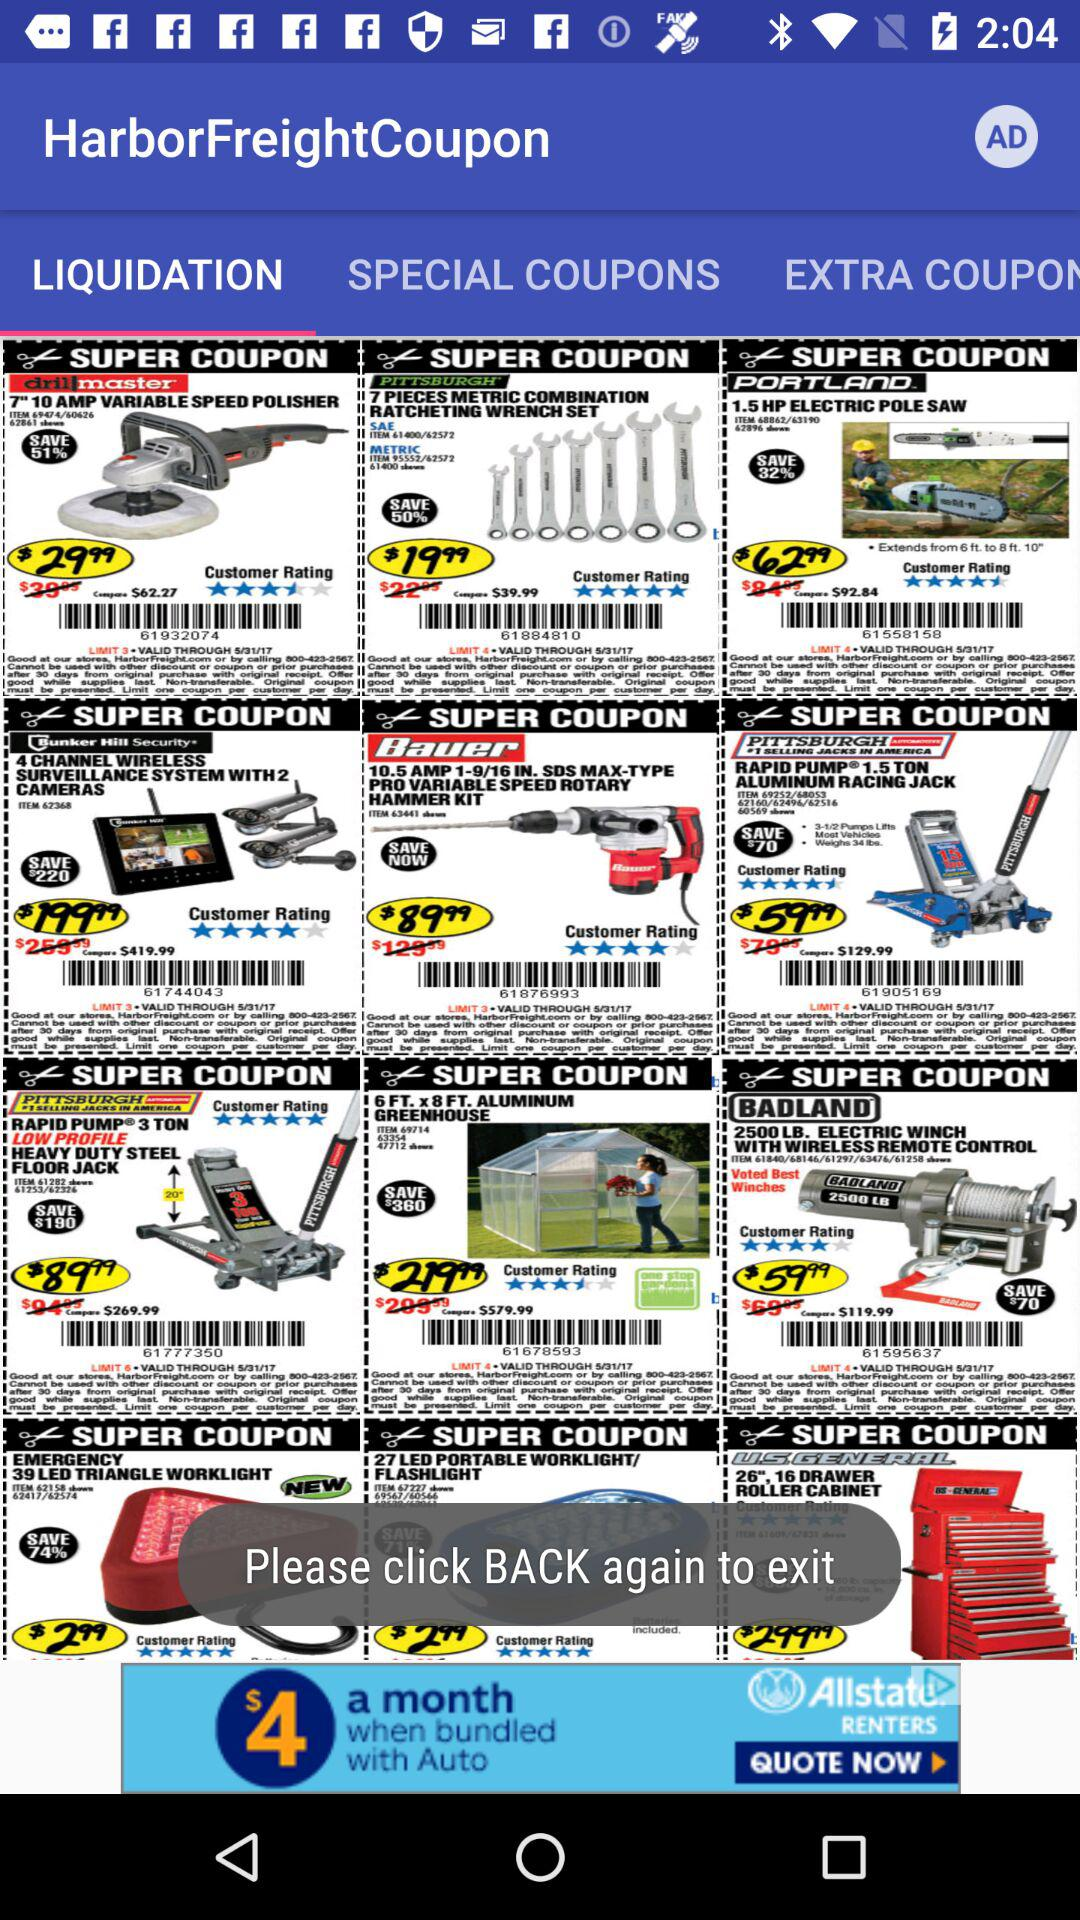Which tab is selected? The selected tab is "LIQUIDATION". 